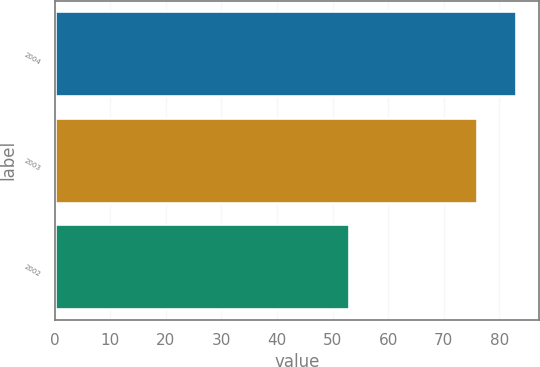Convert chart. <chart><loc_0><loc_0><loc_500><loc_500><bar_chart><fcel>2004<fcel>2003<fcel>2002<nl><fcel>83<fcel>76<fcel>53<nl></chart> 